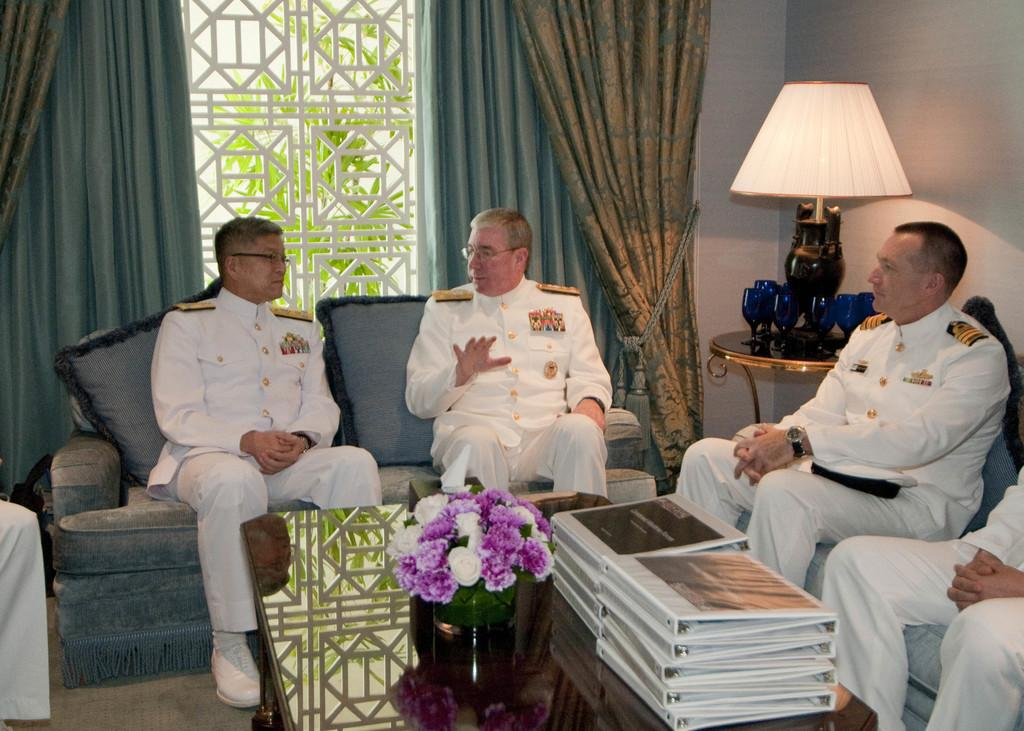Who is present in the image? There are men in the image. What are the men doing in the image? The men are sitting on a sofa. What is in front of the sofa? The sofa is in front of a table. What can be seen on the table? There is a flower pot on the table, as well as other objects. What type of milk is being served during the holiday in the image? There is no mention of milk, a holiday, or any serving in the image. The image only shows men sitting on a sofa with a table in front of them. 